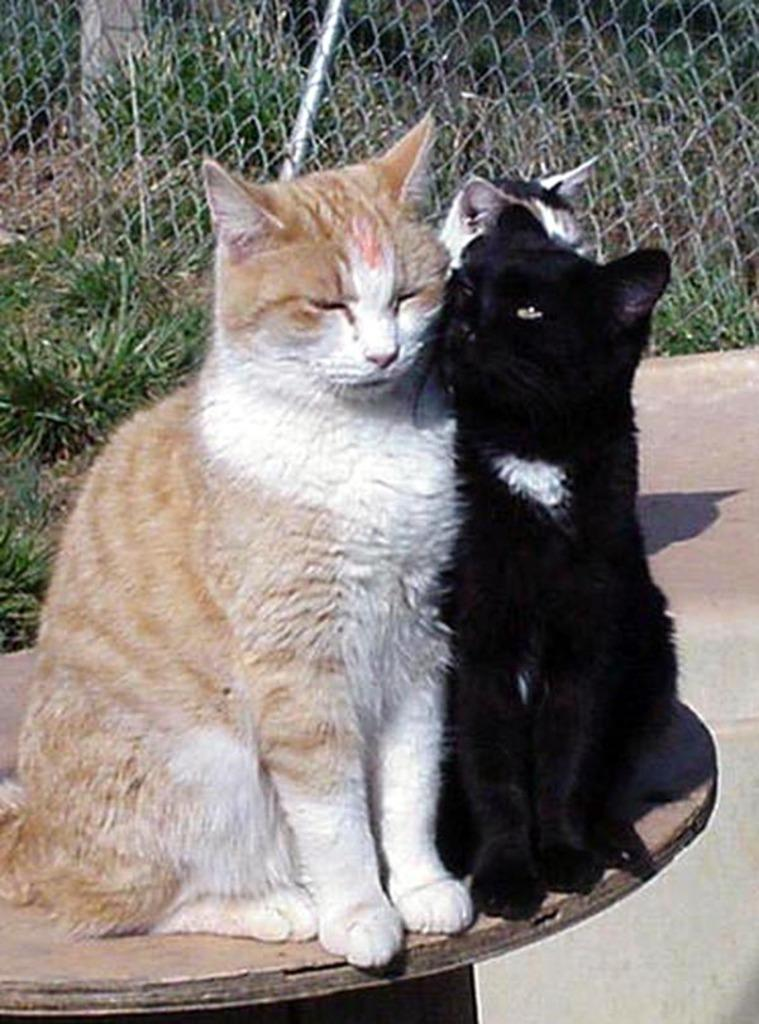How many cats are sitting on the table in the image? There are three cats sitting on the table in the image. What can be seen in the background of the image? There is a fence in the background of the image, and behind the fence, there are plants. What part of the image shows the surface on which the table is placed? The floor is visible at the bottom of the image. What type of paint is being used on the canvas in the image? There is no canvas or paint present in the image; it features three cats sitting on a table with a fence and plants in the background. 